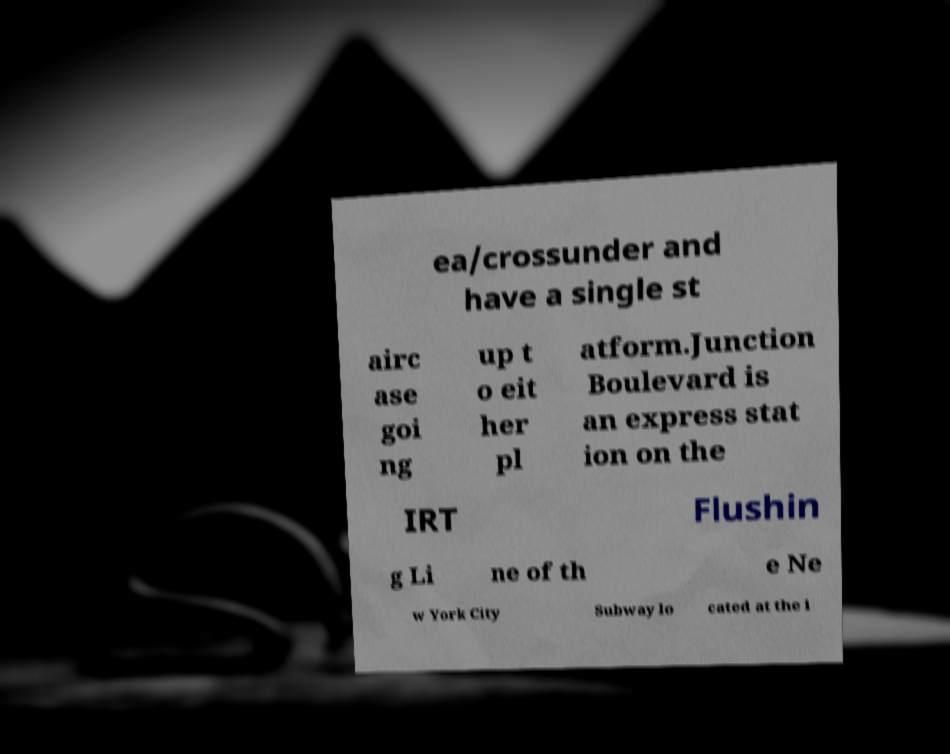I need the written content from this picture converted into text. Can you do that? ea/crossunder and have a single st airc ase goi ng up t o eit her pl atform.Junction Boulevard is an express stat ion on the IRT Flushin g Li ne of th e Ne w York City Subway lo cated at the i 